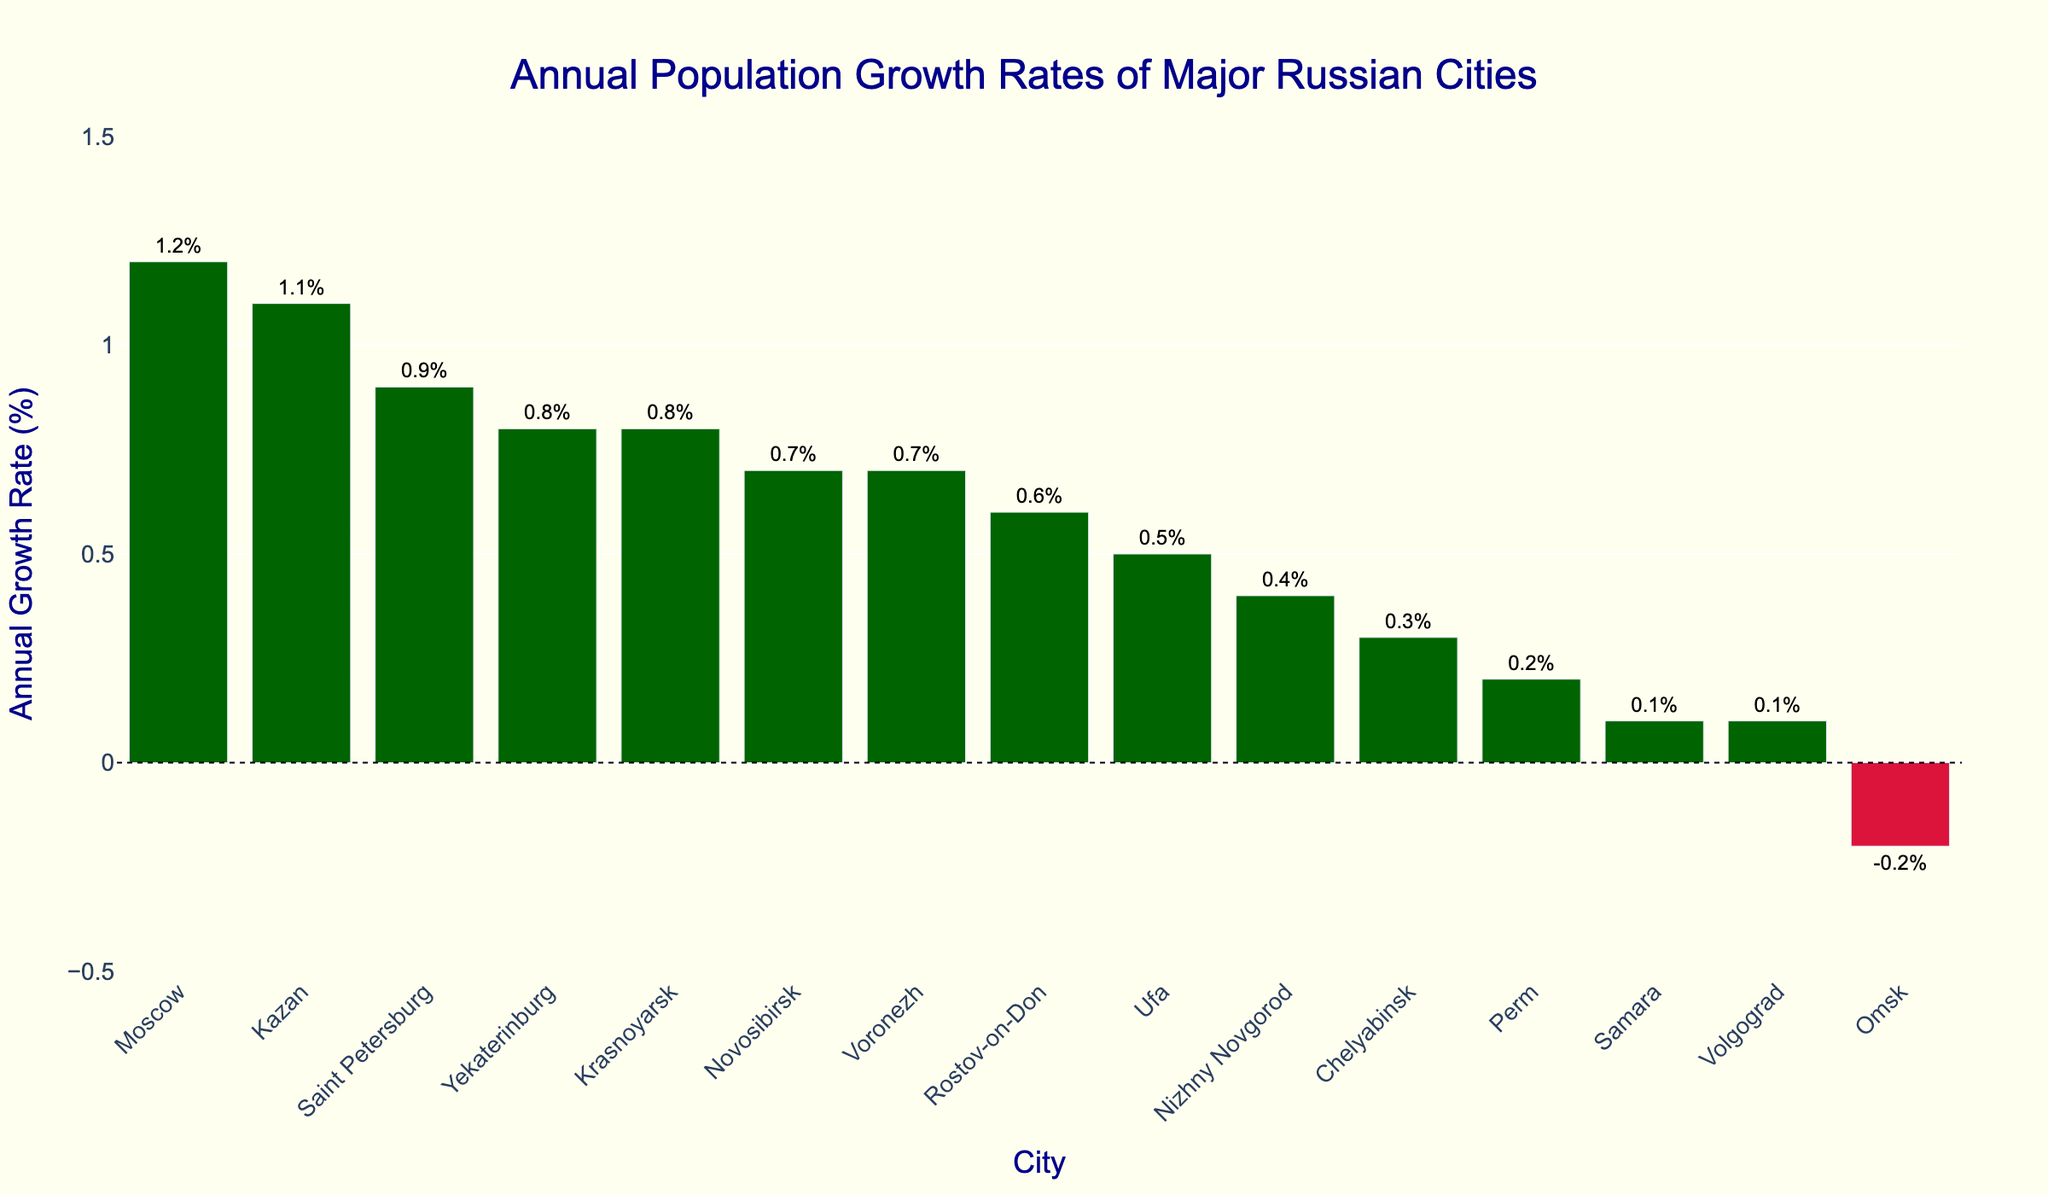Which city has the highest annual growth rate? By looking at the bar height, which indicates the growth rate, Moscow has the highest bar.
Answer: Moscow What is the difference in annual growth rate between Moscow and Kazan? The annual growth rate for Moscow is 1.2%, and for Kazan, it is 1.1%. The difference is 1.2% - 1.1% = 0.1%.
Answer: 0.1% How many cities have a negative annual growth rate? There is one bar colored in crimson (red), indicating a negative growth rate.
Answer: 1 Which cities have an annual growth rate below 0.5%? The bars with heights less than 0.5% are for Nizhny Novgorod, Chelyabinsk, Omsk, Samara, Perm, and Volgograd.
Answer: Nizhny Novgorod, Chelyabinsk, Omsk, Samara, Perm, Volgograd What is the average annual growth rate of Russian cities with a positive annual growth rate? Sum the annual growth rates of cities with positive values and divide by the number of those cities: (1.2 + 0.9 + 0.7 + 0.8 + 1.1 + 0.4 + 0.3 + 0.1 + 0.6 + 0.5 + 0.8 + 0.7 + 0.2 + 0.1) / 14 = 0.607142857 or approximately 0.61%.
Answer: 0.61% 